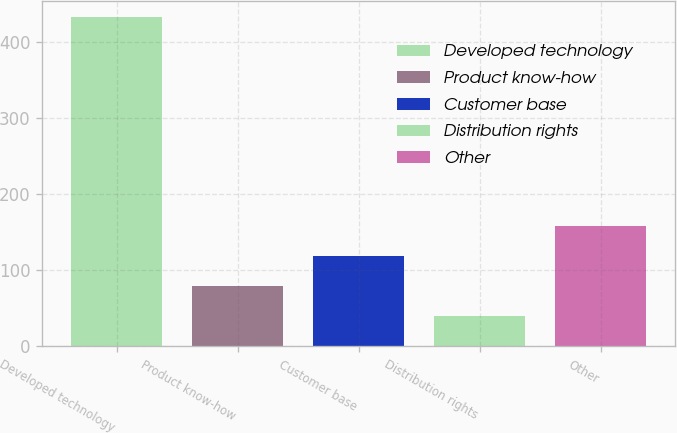Convert chart to OTSL. <chart><loc_0><loc_0><loc_500><loc_500><bar_chart><fcel>Developed technology<fcel>Product know-how<fcel>Customer base<fcel>Distribution rights<fcel>Other<nl><fcel>432<fcel>79.2<fcel>118.4<fcel>40<fcel>157.6<nl></chart> 